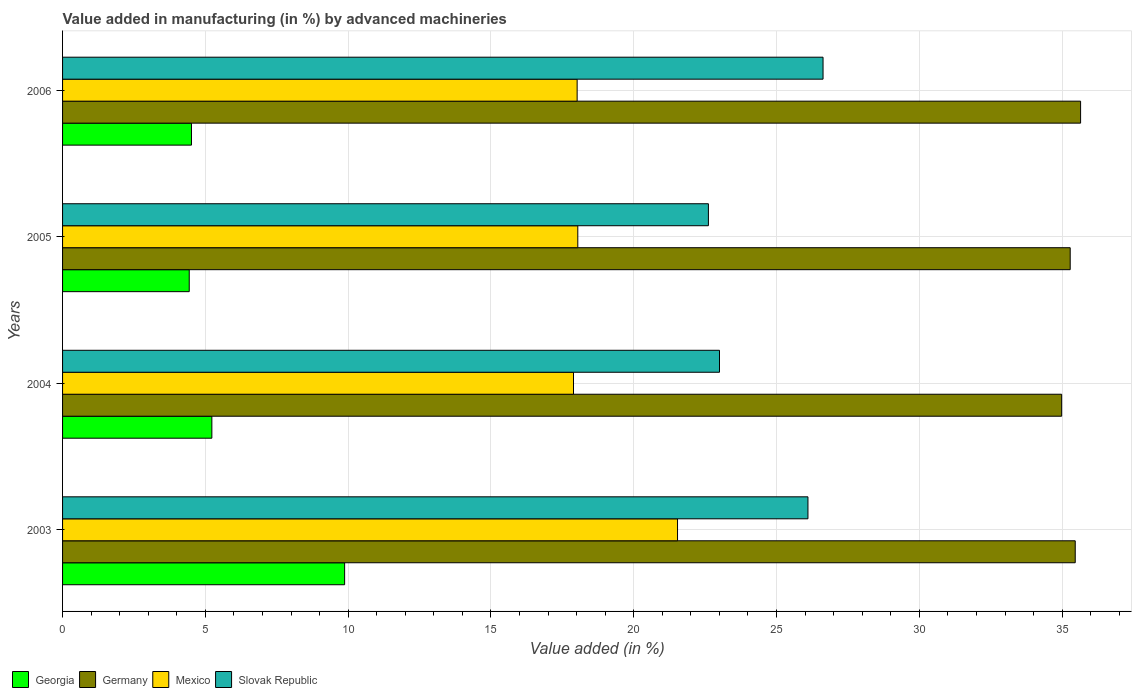How many different coloured bars are there?
Offer a very short reply. 4. Are the number of bars per tick equal to the number of legend labels?
Your answer should be compact. Yes. Are the number of bars on each tick of the Y-axis equal?
Make the answer very short. Yes. How many bars are there on the 2nd tick from the bottom?
Give a very brief answer. 4. What is the label of the 1st group of bars from the top?
Provide a short and direct response. 2006. What is the percentage of value added in manufacturing by advanced machineries in Slovak Republic in 2004?
Keep it short and to the point. 23. Across all years, what is the maximum percentage of value added in manufacturing by advanced machineries in Georgia?
Provide a succinct answer. 9.88. Across all years, what is the minimum percentage of value added in manufacturing by advanced machineries in Slovak Republic?
Offer a very short reply. 22.61. In which year was the percentage of value added in manufacturing by advanced machineries in Mexico maximum?
Your response must be concise. 2003. What is the total percentage of value added in manufacturing by advanced machineries in Mexico in the graph?
Your answer should be very brief. 75.48. What is the difference between the percentage of value added in manufacturing by advanced machineries in Georgia in 2005 and that in 2006?
Provide a succinct answer. -0.08. What is the difference between the percentage of value added in manufacturing by advanced machineries in Germany in 2006 and the percentage of value added in manufacturing by advanced machineries in Slovak Republic in 2005?
Ensure brevity in your answer.  13.03. What is the average percentage of value added in manufacturing by advanced machineries in Slovak Republic per year?
Keep it short and to the point. 24.59. In the year 2006, what is the difference between the percentage of value added in manufacturing by advanced machineries in Georgia and percentage of value added in manufacturing by advanced machineries in Germany?
Ensure brevity in your answer.  -31.13. What is the ratio of the percentage of value added in manufacturing by advanced machineries in Georgia in 2004 to that in 2006?
Your answer should be compact. 1.16. What is the difference between the highest and the second highest percentage of value added in manufacturing by advanced machineries in Mexico?
Your response must be concise. 3.49. What is the difference between the highest and the lowest percentage of value added in manufacturing by advanced machineries in Georgia?
Give a very brief answer. 5.44. In how many years, is the percentage of value added in manufacturing by advanced machineries in Georgia greater than the average percentage of value added in manufacturing by advanced machineries in Georgia taken over all years?
Your response must be concise. 1. Is the sum of the percentage of value added in manufacturing by advanced machineries in Slovak Republic in 2004 and 2005 greater than the maximum percentage of value added in manufacturing by advanced machineries in Georgia across all years?
Offer a very short reply. Yes. What does the 4th bar from the top in 2004 represents?
Provide a short and direct response. Georgia. What does the 4th bar from the bottom in 2004 represents?
Ensure brevity in your answer.  Slovak Republic. Is it the case that in every year, the sum of the percentage of value added in manufacturing by advanced machineries in Georgia and percentage of value added in manufacturing by advanced machineries in Slovak Republic is greater than the percentage of value added in manufacturing by advanced machineries in Mexico?
Provide a short and direct response. Yes. Are all the bars in the graph horizontal?
Provide a succinct answer. Yes. Are the values on the major ticks of X-axis written in scientific E-notation?
Provide a succinct answer. No. Does the graph contain any zero values?
Offer a terse response. No. Does the graph contain grids?
Offer a terse response. Yes. How many legend labels are there?
Offer a terse response. 4. What is the title of the graph?
Your answer should be very brief. Value added in manufacturing (in %) by advanced machineries. Does "Bhutan" appear as one of the legend labels in the graph?
Ensure brevity in your answer.  No. What is the label or title of the X-axis?
Provide a short and direct response. Value added (in %). What is the Value added (in %) of Georgia in 2003?
Offer a terse response. 9.88. What is the Value added (in %) in Germany in 2003?
Provide a short and direct response. 35.46. What is the Value added (in %) of Mexico in 2003?
Give a very brief answer. 21.53. What is the Value added (in %) of Slovak Republic in 2003?
Provide a short and direct response. 26.1. What is the Value added (in %) in Georgia in 2004?
Your answer should be compact. 5.23. What is the Value added (in %) of Germany in 2004?
Your response must be concise. 34.98. What is the Value added (in %) in Mexico in 2004?
Offer a terse response. 17.89. What is the Value added (in %) in Slovak Republic in 2004?
Offer a very short reply. 23. What is the Value added (in %) in Georgia in 2005?
Provide a short and direct response. 4.44. What is the Value added (in %) of Germany in 2005?
Your response must be concise. 35.28. What is the Value added (in %) in Mexico in 2005?
Your answer should be very brief. 18.04. What is the Value added (in %) of Slovak Republic in 2005?
Ensure brevity in your answer.  22.61. What is the Value added (in %) in Georgia in 2006?
Your answer should be compact. 4.51. What is the Value added (in %) of Germany in 2006?
Your answer should be very brief. 35.65. What is the Value added (in %) of Mexico in 2006?
Your answer should be compact. 18.02. What is the Value added (in %) in Slovak Republic in 2006?
Provide a succinct answer. 26.63. Across all years, what is the maximum Value added (in %) of Georgia?
Keep it short and to the point. 9.88. Across all years, what is the maximum Value added (in %) of Germany?
Your answer should be very brief. 35.65. Across all years, what is the maximum Value added (in %) of Mexico?
Your answer should be very brief. 21.53. Across all years, what is the maximum Value added (in %) in Slovak Republic?
Offer a very short reply. 26.63. Across all years, what is the minimum Value added (in %) of Georgia?
Your response must be concise. 4.44. Across all years, what is the minimum Value added (in %) in Germany?
Your response must be concise. 34.98. Across all years, what is the minimum Value added (in %) of Mexico?
Make the answer very short. 17.89. Across all years, what is the minimum Value added (in %) in Slovak Republic?
Your answer should be very brief. 22.61. What is the total Value added (in %) of Georgia in the graph?
Your answer should be very brief. 24.05. What is the total Value added (in %) in Germany in the graph?
Give a very brief answer. 141.37. What is the total Value added (in %) of Mexico in the graph?
Offer a terse response. 75.48. What is the total Value added (in %) of Slovak Republic in the graph?
Your answer should be very brief. 98.34. What is the difference between the Value added (in %) of Georgia in 2003 and that in 2004?
Provide a short and direct response. 4.65. What is the difference between the Value added (in %) in Germany in 2003 and that in 2004?
Your answer should be compact. 0.48. What is the difference between the Value added (in %) of Mexico in 2003 and that in 2004?
Make the answer very short. 3.64. What is the difference between the Value added (in %) of Slovak Republic in 2003 and that in 2004?
Your answer should be very brief. 3.1. What is the difference between the Value added (in %) of Georgia in 2003 and that in 2005?
Your answer should be compact. 5.44. What is the difference between the Value added (in %) in Germany in 2003 and that in 2005?
Offer a very short reply. 0.18. What is the difference between the Value added (in %) in Mexico in 2003 and that in 2005?
Keep it short and to the point. 3.49. What is the difference between the Value added (in %) in Slovak Republic in 2003 and that in 2005?
Provide a short and direct response. 3.49. What is the difference between the Value added (in %) in Georgia in 2003 and that in 2006?
Offer a very short reply. 5.36. What is the difference between the Value added (in %) in Germany in 2003 and that in 2006?
Offer a very short reply. -0.19. What is the difference between the Value added (in %) in Mexico in 2003 and that in 2006?
Provide a short and direct response. 3.52. What is the difference between the Value added (in %) in Slovak Republic in 2003 and that in 2006?
Make the answer very short. -0.53. What is the difference between the Value added (in %) of Georgia in 2004 and that in 2005?
Make the answer very short. 0.79. What is the difference between the Value added (in %) of Germany in 2004 and that in 2005?
Ensure brevity in your answer.  -0.3. What is the difference between the Value added (in %) of Mexico in 2004 and that in 2005?
Offer a very short reply. -0.15. What is the difference between the Value added (in %) in Slovak Republic in 2004 and that in 2005?
Provide a short and direct response. 0.39. What is the difference between the Value added (in %) in Georgia in 2004 and that in 2006?
Make the answer very short. 0.71. What is the difference between the Value added (in %) of Germany in 2004 and that in 2006?
Offer a very short reply. -0.66. What is the difference between the Value added (in %) of Mexico in 2004 and that in 2006?
Ensure brevity in your answer.  -0.13. What is the difference between the Value added (in %) of Slovak Republic in 2004 and that in 2006?
Your answer should be very brief. -3.63. What is the difference between the Value added (in %) of Georgia in 2005 and that in 2006?
Make the answer very short. -0.08. What is the difference between the Value added (in %) in Germany in 2005 and that in 2006?
Your answer should be compact. -0.36. What is the difference between the Value added (in %) of Mexico in 2005 and that in 2006?
Your response must be concise. 0.02. What is the difference between the Value added (in %) in Slovak Republic in 2005 and that in 2006?
Ensure brevity in your answer.  -4.01. What is the difference between the Value added (in %) of Georgia in 2003 and the Value added (in %) of Germany in 2004?
Keep it short and to the point. -25.11. What is the difference between the Value added (in %) in Georgia in 2003 and the Value added (in %) in Mexico in 2004?
Ensure brevity in your answer.  -8.01. What is the difference between the Value added (in %) in Georgia in 2003 and the Value added (in %) in Slovak Republic in 2004?
Your answer should be compact. -13.13. What is the difference between the Value added (in %) in Germany in 2003 and the Value added (in %) in Mexico in 2004?
Offer a terse response. 17.57. What is the difference between the Value added (in %) in Germany in 2003 and the Value added (in %) in Slovak Republic in 2004?
Offer a terse response. 12.46. What is the difference between the Value added (in %) in Mexico in 2003 and the Value added (in %) in Slovak Republic in 2004?
Offer a very short reply. -1.47. What is the difference between the Value added (in %) of Georgia in 2003 and the Value added (in %) of Germany in 2005?
Your answer should be very brief. -25.41. What is the difference between the Value added (in %) in Georgia in 2003 and the Value added (in %) in Mexico in 2005?
Your response must be concise. -8.16. What is the difference between the Value added (in %) of Georgia in 2003 and the Value added (in %) of Slovak Republic in 2005?
Your answer should be very brief. -12.74. What is the difference between the Value added (in %) of Germany in 2003 and the Value added (in %) of Mexico in 2005?
Ensure brevity in your answer.  17.42. What is the difference between the Value added (in %) in Germany in 2003 and the Value added (in %) in Slovak Republic in 2005?
Keep it short and to the point. 12.84. What is the difference between the Value added (in %) in Mexico in 2003 and the Value added (in %) in Slovak Republic in 2005?
Offer a very short reply. -1.08. What is the difference between the Value added (in %) of Georgia in 2003 and the Value added (in %) of Germany in 2006?
Offer a terse response. -25.77. What is the difference between the Value added (in %) in Georgia in 2003 and the Value added (in %) in Mexico in 2006?
Provide a succinct answer. -8.14. What is the difference between the Value added (in %) of Georgia in 2003 and the Value added (in %) of Slovak Republic in 2006?
Keep it short and to the point. -16.75. What is the difference between the Value added (in %) of Germany in 2003 and the Value added (in %) of Mexico in 2006?
Offer a terse response. 17.44. What is the difference between the Value added (in %) in Germany in 2003 and the Value added (in %) in Slovak Republic in 2006?
Your answer should be compact. 8.83. What is the difference between the Value added (in %) in Mexico in 2003 and the Value added (in %) in Slovak Republic in 2006?
Provide a short and direct response. -5.1. What is the difference between the Value added (in %) in Georgia in 2004 and the Value added (in %) in Germany in 2005?
Your answer should be very brief. -30.05. What is the difference between the Value added (in %) of Georgia in 2004 and the Value added (in %) of Mexico in 2005?
Keep it short and to the point. -12.81. What is the difference between the Value added (in %) of Georgia in 2004 and the Value added (in %) of Slovak Republic in 2005?
Your response must be concise. -17.39. What is the difference between the Value added (in %) of Germany in 2004 and the Value added (in %) of Mexico in 2005?
Offer a terse response. 16.94. What is the difference between the Value added (in %) in Germany in 2004 and the Value added (in %) in Slovak Republic in 2005?
Keep it short and to the point. 12.37. What is the difference between the Value added (in %) of Mexico in 2004 and the Value added (in %) of Slovak Republic in 2005?
Your answer should be very brief. -4.72. What is the difference between the Value added (in %) of Georgia in 2004 and the Value added (in %) of Germany in 2006?
Ensure brevity in your answer.  -30.42. What is the difference between the Value added (in %) in Georgia in 2004 and the Value added (in %) in Mexico in 2006?
Provide a short and direct response. -12.79. What is the difference between the Value added (in %) in Georgia in 2004 and the Value added (in %) in Slovak Republic in 2006?
Your answer should be compact. -21.4. What is the difference between the Value added (in %) of Germany in 2004 and the Value added (in %) of Mexico in 2006?
Provide a succinct answer. 16.97. What is the difference between the Value added (in %) in Germany in 2004 and the Value added (in %) in Slovak Republic in 2006?
Your response must be concise. 8.36. What is the difference between the Value added (in %) of Mexico in 2004 and the Value added (in %) of Slovak Republic in 2006?
Ensure brevity in your answer.  -8.74. What is the difference between the Value added (in %) in Georgia in 2005 and the Value added (in %) in Germany in 2006?
Offer a very short reply. -31.21. What is the difference between the Value added (in %) in Georgia in 2005 and the Value added (in %) in Mexico in 2006?
Make the answer very short. -13.58. What is the difference between the Value added (in %) in Georgia in 2005 and the Value added (in %) in Slovak Republic in 2006?
Ensure brevity in your answer.  -22.19. What is the difference between the Value added (in %) of Germany in 2005 and the Value added (in %) of Mexico in 2006?
Ensure brevity in your answer.  17.26. What is the difference between the Value added (in %) of Germany in 2005 and the Value added (in %) of Slovak Republic in 2006?
Ensure brevity in your answer.  8.65. What is the difference between the Value added (in %) in Mexico in 2005 and the Value added (in %) in Slovak Republic in 2006?
Provide a short and direct response. -8.59. What is the average Value added (in %) of Georgia per year?
Your answer should be very brief. 6.01. What is the average Value added (in %) in Germany per year?
Keep it short and to the point. 35.34. What is the average Value added (in %) of Mexico per year?
Your response must be concise. 18.87. What is the average Value added (in %) in Slovak Republic per year?
Provide a short and direct response. 24.59. In the year 2003, what is the difference between the Value added (in %) in Georgia and Value added (in %) in Germany?
Your answer should be very brief. -25.58. In the year 2003, what is the difference between the Value added (in %) in Georgia and Value added (in %) in Mexico?
Keep it short and to the point. -11.66. In the year 2003, what is the difference between the Value added (in %) of Georgia and Value added (in %) of Slovak Republic?
Offer a very short reply. -16.22. In the year 2003, what is the difference between the Value added (in %) of Germany and Value added (in %) of Mexico?
Keep it short and to the point. 13.93. In the year 2003, what is the difference between the Value added (in %) of Germany and Value added (in %) of Slovak Republic?
Your answer should be compact. 9.36. In the year 2003, what is the difference between the Value added (in %) in Mexico and Value added (in %) in Slovak Republic?
Your answer should be very brief. -4.57. In the year 2004, what is the difference between the Value added (in %) in Georgia and Value added (in %) in Germany?
Offer a terse response. -29.76. In the year 2004, what is the difference between the Value added (in %) in Georgia and Value added (in %) in Mexico?
Provide a succinct answer. -12.66. In the year 2004, what is the difference between the Value added (in %) in Georgia and Value added (in %) in Slovak Republic?
Offer a terse response. -17.77. In the year 2004, what is the difference between the Value added (in %) of Germany and Value added (in %) of Mexico?
Provide a short and direct response. 17.09. In the year 2004, what is the difference between the Value added (in %) in Germany and Value added (in %) in Slovak Republic?
Give a very brief answer. 11.98. In the year 2004, what is the difference between the Value added (in %) in Mexico and Value added (in %) in Slovak Republic?
Ensure brevity in your answer.  -5.11. In the year 2005, what is the difference between the Value added (in %) in Georgia and Value added (in %) in Germany?
Your answer should be very brief. -30.85. In the year 2005, what is the difference between the Value added (in %) in Georgia and Value added (in %) in Mexico?
Provide a succinct answer. -13.61. In the year 2005, what is the difference between the Value added (in %) of Georgia and Value added (in %) of Slovak Republic?
Ensure brevity in your answer.  -18.18. In the year 2005, what is the difference between the Value added (in %) in Germany and Value added (in %) in Mexico?
Keep it short and to the point. 17.24. In the year 2005, what is the difference between the Value added (in %) in Germany and Value added (in %) in Slovak Republic?
Your answer should be very brief. 12.67. In the year 2005, what is the difference between the Value added (in %) of Mexico and Value added (in %) of Slovak Republic?
Offer a terse response. -4.57. In the year 2006, what is the difference between the Value added (in %) of Georgia and Value added (in %) of Germany?
Make the answer very short. -31.13. In the year 2006, what is the difference between the Value added (in %) of Georgia and Value added (in %) of Mexico?
Your response must be concise. -13.5. In the year 2006, what is the difference between the Value added (in %) in Georgia and Value added (in %) in Slovak Republic?
Offer a terse response. -22.11. In the year 2006, what is the difference between the Value added (in %) in Germany and Value added (in %) in Mexico?
Provide a succinct answer. 17.63. In the year 2006, what is the difference between the Value added (in %) of Germany and Value added (in %) of Slovak Republic?
Provide a short and direct response. 9.02. In the year 2006, what is the difference between the Value added (in %) of Mexico and Value added (in %) of Slovak Republic?
Make the answer very short. -8.61. What is the ratio of the Value added (in %) of Georgia in 2003 to that in 2004?
Offer a terse response. 1.89. What is the ratio of the Value added (in %) in Germany in 2003 to that in 2004?
Your response must be concise. 1.01. What is the ratio of the Value added (in %) of Mexico in 2003 to that in 2004?
Your answer should be compact. 1.2. What is the ratio of the Value added (in %) of Slovak Republic in 2003 to that in 2004?
Your answer should be very brief. 1.13. What is the ratio of the Value added (in %) in Georgia in 2003 to that in 2005?
Ensure brevity in your answer.  2.23. What is the ratio of the Value added (in %) of Germany in 2003 to that in 2005?
Your answer should be compact. 1. What is the ratio of the Value added (in %) in Mexico in 2003 to that in 2005?
Give a very brief answer. 1.19. What is the ratio of the Value added (in %) in Slovak Republic in 2003 to that in 2005?
Keep it short and to the point. 1.15. What is the ratio of the Value added (in %) in Georgia in 2003 to that in 2006?
Your answer should be compact. 2.19. What is the ratio of the Value added (in %) of Mexico in 2003 to that in 2006?
Your answer should be compact. 1.2. What is the ratio of the Value added (in %) of Slovak Republic in 2003 to that in 2006?
Keep it short and to the point. 0.98. What is the ratio of the Value added (in %) in Georgia in 2004 to that in 2005?
Provide a succinct answer. 1.18. What is the ratio of the Value added (in %) of Mexico in 2004 to that in 2005?
Keep it short and to the point. 0.99. What is the ratio of the Value added (in %) in Slovak Republic in 2004 to that in 2005?
Offer a very short reply. 1.02. What is the ratio of the Value added (in %) of Georgia in 2004 to that in 2006?
Offer a terse response. 1.16. What is the ratio of the Value added (in %) of Germany in 2004 to that in 2006?
Give a very brief answer. 0.98. What is the ratio of the Value added (in %) in Mexico in 2004 to that in 2006?
Give a very brief answer. 0.99. What is the ratio of the Value added (in %) in Slovak Republic in 2004 to that in 2006?
Provide a succinct answer. 0.86. What is the ratio of the Value added (in %) in Georgia in 2005 to that in 2006?
Keep it short and to the point. 0.98. What is the ratio of the Value added (in %) of Germany in 2005 to that in 2006?
Your answer should be very brief. 0.99. What is the ratio of the Value added (in %) of Mexico in 2005 to that in 2006?
Your response must be concise. 1. What is the ratio of the Value added (in %) in Slovak Republic in 2005 to that in 2006?
Your response must be concise. 0.85. What is the difference between the highest and the second highest Value added (in %) of Georgia?
Keep it short and to the point. 4.65. What is the difference between the highest and the second highest Value added (in %) of Germany?
Your answer should be very brief. 0.19. What is the difference between the highest and the second highest Value added (in %) of Mexico?
Your answer should be very brief. 3.49. What is the difference between the highest and the second highest Value added (in %) of Slovak Republic?
Offer a very short reply. 0.53. What is the difference between the highest and the lowest Value added (in %) of Georgia?
Your answer should be very brief. 5.44. What is the difference between the highest and the lowest Value added (in %) of Germany?
Make the answer very short. 0.66. What is the difference between the highest and the lowest Value added (in %) in Mexico?
Offer a very short reply. 3.64. What is the difference between the highest and the lowest Value added (in %) of Slovak Republic?
Make the answer very short. 4.01. 